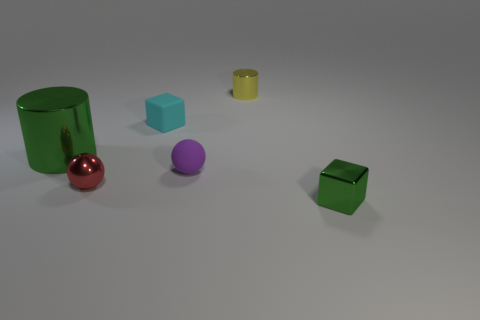Add 2 tiny yellow things. How many objects exist? 8 Subtract all cylinders. How many objects are left? 4 Add 2 tiny objects. How many tiny objects exist? 7 Subtract 1 yellow cylinders. How many objects are left? 5 Subtract all tiny green metallic things. Subtract all tiny cyan blocks. How many objects are left? 4 Add 2 small red metal balls. How many small red metal balls are left? 3 